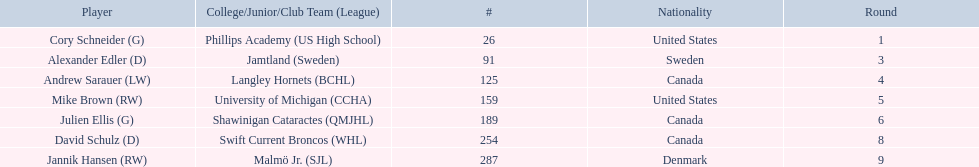What are the names of the colleges and jr leagues the players attended? Phillips Academy (US High School), Jamtland (Sweden), Langley Hornets (BCHL), University of Michigan (CCHA), Shawinigan Cataractes (QMJHL), Swift Current Broncos (WHL), Malmö Jr. (SJL). Which player played for the langley hornets? Andrew Sarauer (LW). 